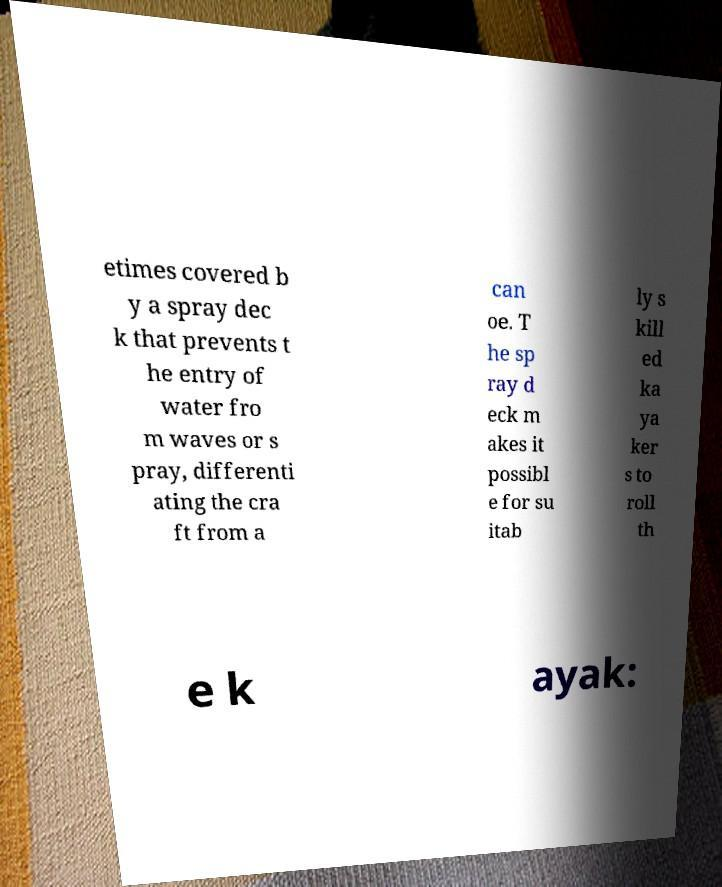There's text embedded in this image that I need extracted. Can you transcribe it verbatim? etimes covered b y a spray dec k that prevents t he entry of water fro m waves or s pray, differenti ating the cra ft from a can oe. T he sp ray d eck m akes it possibl e for su itab ly s kill ed ka ya ker s to roll th e k ayak: 